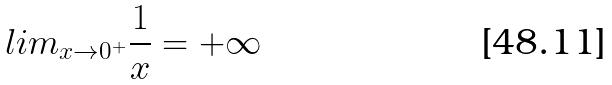Convert formula to latex. <formula><loc_0><loc_0><loc_500><loc_500>l i m _ { x \rightarrow 0 ^ { + } } \frac { 1 } { x } = + \infty</formula> 